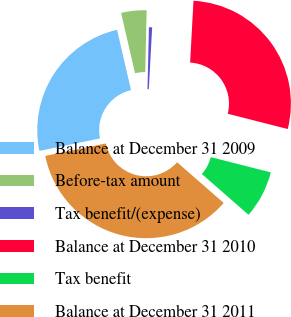<chart> <loc_0><loc_0><loc_500><loc_500><pie_chart><fcel>Balance at December 31 2009<fcel>Before-tax amount<fcel>Tax benefit/(expense)<fcel>Balance at December 31 2010<fcel>Tax benefit<fcel>Balance at December 31 2011<nl><fcel>24.61%<fcel>3.98%<fcel>0.5%<fcel>28.1%<fcel>7.47%<fcel>35.34%<nl></chart> 